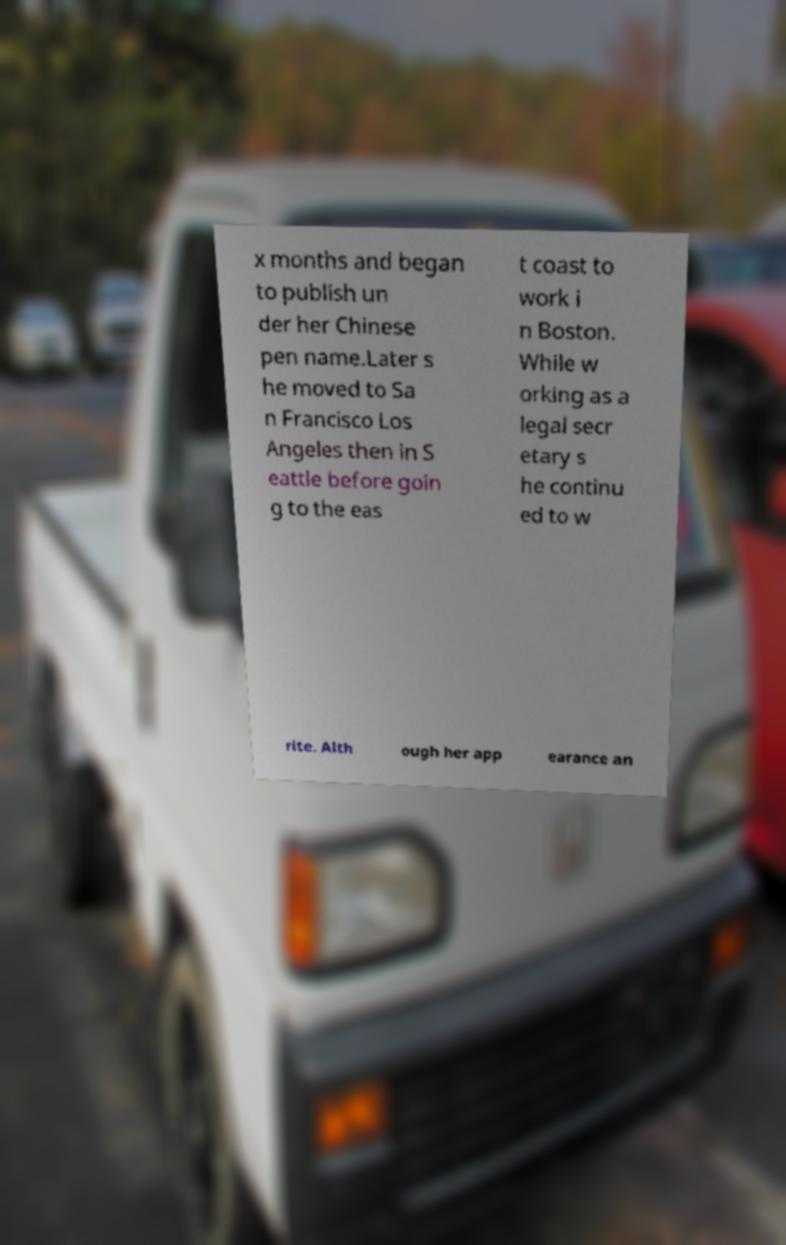For documentation purposes, I need the text within this image transcribed. Could you provide that? x months and began to publish un der her Chinese pen name.Later s he moved to Sa n Francisco Los Angeles then in S eattle before goin g to the eas t coast to work i n Boston. While w orking as a legal secr etary s he continu ed to w rite. Alth ough her app earance an 